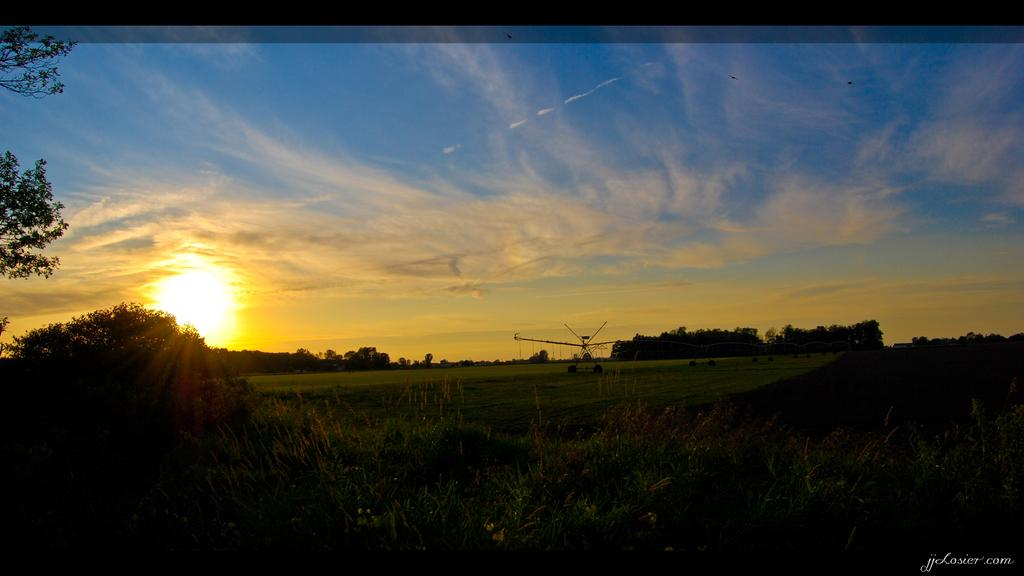What is located in the middle of the image? There are trees, plants, and grass in the middle of the image. What is visible at the top of the image? The sun, sky, and clouds are visible at the top of the image. What can be found at the bottom of the image? There is text at the bottom of the image. What color is the dress worn by the person in the image? There is no person wearing a dress in the image; it features trees, plants, grass, and text. How much blood can be seen on the ground in the image? There is no blood present in the image; it features trees, plants, grass, text, the sun, sky, and clouds. 